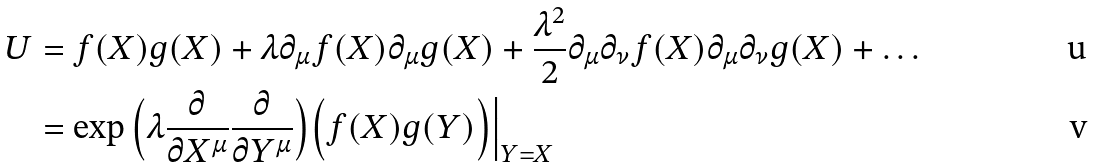Convert formula to latex. <formula><loc_0><loc_0><loc_500><loc_500>U & = f ( X ) g ( X ) + \lambda \partial _ { \mu } f ( X ) \partial _ { \mu } g ( X ) + \frac { \lambda ^ { 2 } } { 2 } \partial _ { \mu } \partial _ { \nu } f ( X ) \partial _ { \mu } \partial _ { \nu } g ( X ) + \dots \\ & = \exp \Big ( \lambda \frac { \partial } { \partial X ^ { \mu } } \frac { \partial } { \partial Y ^ { \mu } } \Big ) \Big ( f ( X ) g ( Y ) \Big ) \Big | _ { Y = X }</formula> 